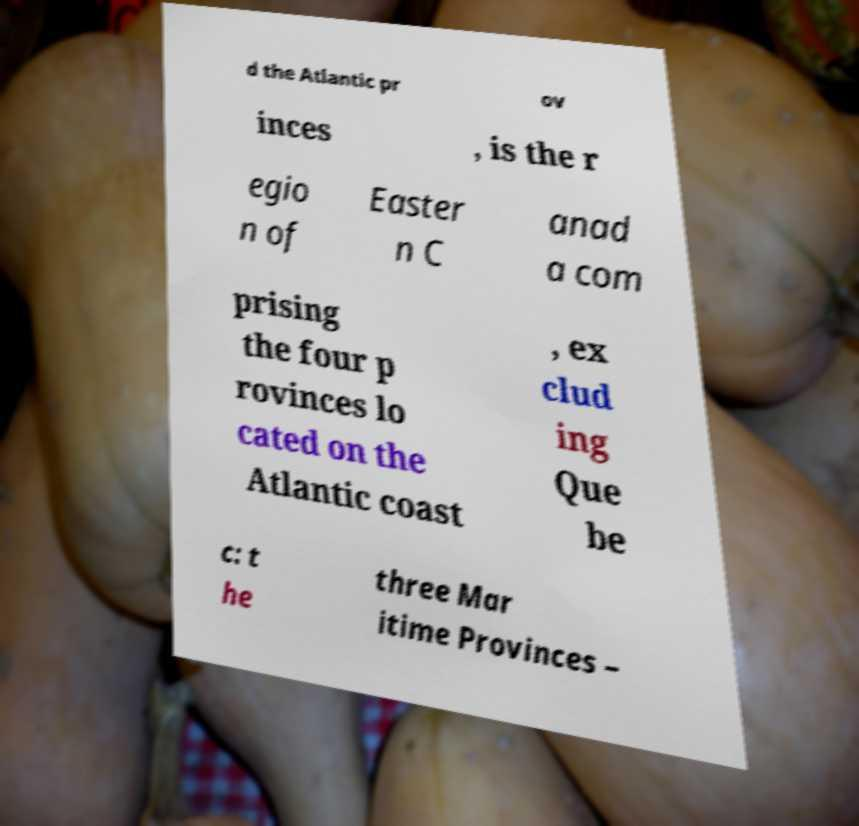Could you extract and type out the text from this image? d the Atlantic pr ov inces , is the r egio n of Easter n C anad a com prising the four p rovinces lo cated on the Atlantic coast , ex clud ing Que be c: t he three Mar itime Provinces – 